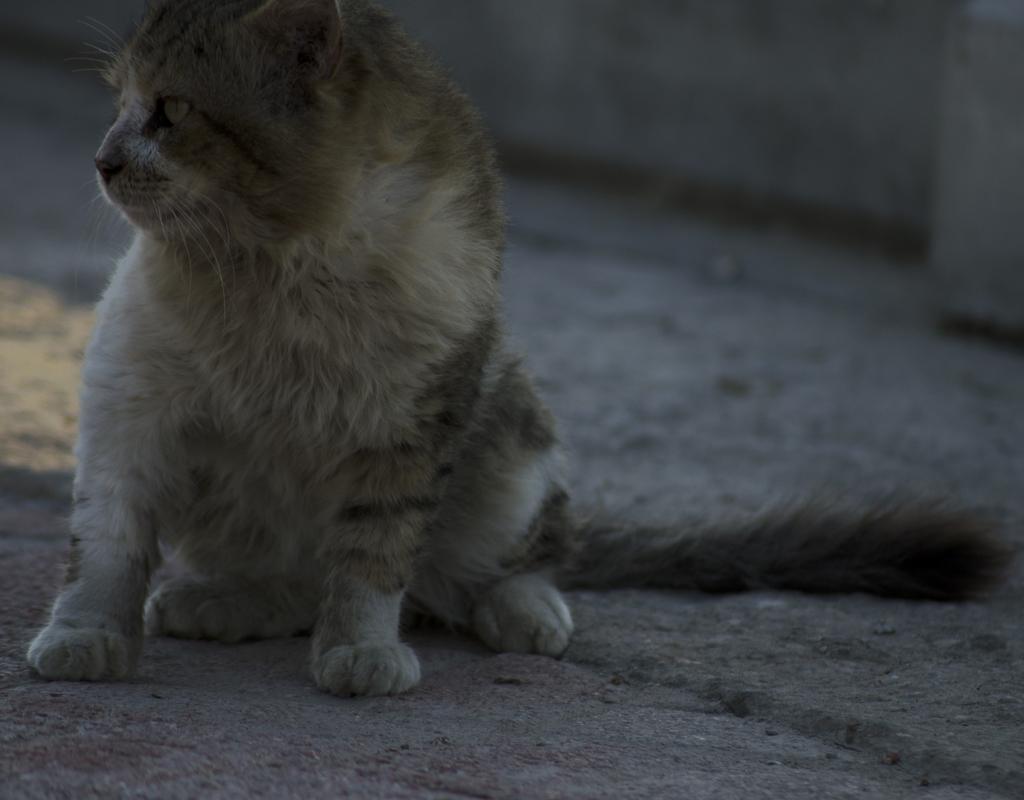Can you describe this image briefly? In this image I can see a cat on the ground. In the background, I can see the wall. 